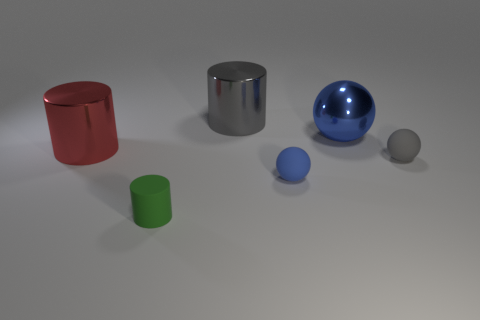Is there a pattern to the arrangement of these objects? Not necessarily a specific pattern, but there is a clear left to right gradient in size and a grouping by color, with the blue objects towards the right indicating some level of deliberate placement. Do these objects have a real-world function, or do they seem purely decorative? These objects resemble simple geometric shapes often used in demonstrations or educational settings, so they may not have a direct real-world function, but rather serve a demonstrative or ornamental purpose. 